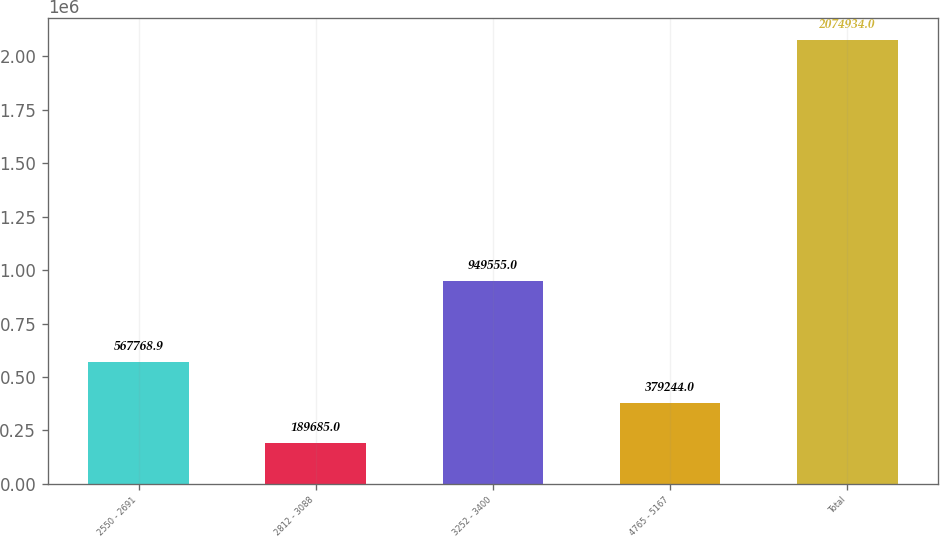Convert chart to OTSL. <chart><loc_0><loc_0><loc_500><loc_500><bar_chart><fcel>2550 - 2691<fcel>2812 - 3088<fcel>3252 - 3400<fcel>4765 - 5167<fcel>Total<nl><fcel>567769<fcel>189685<fcel>949555<fcel>379244<fcel>2.07493e+06<nl></chart> 